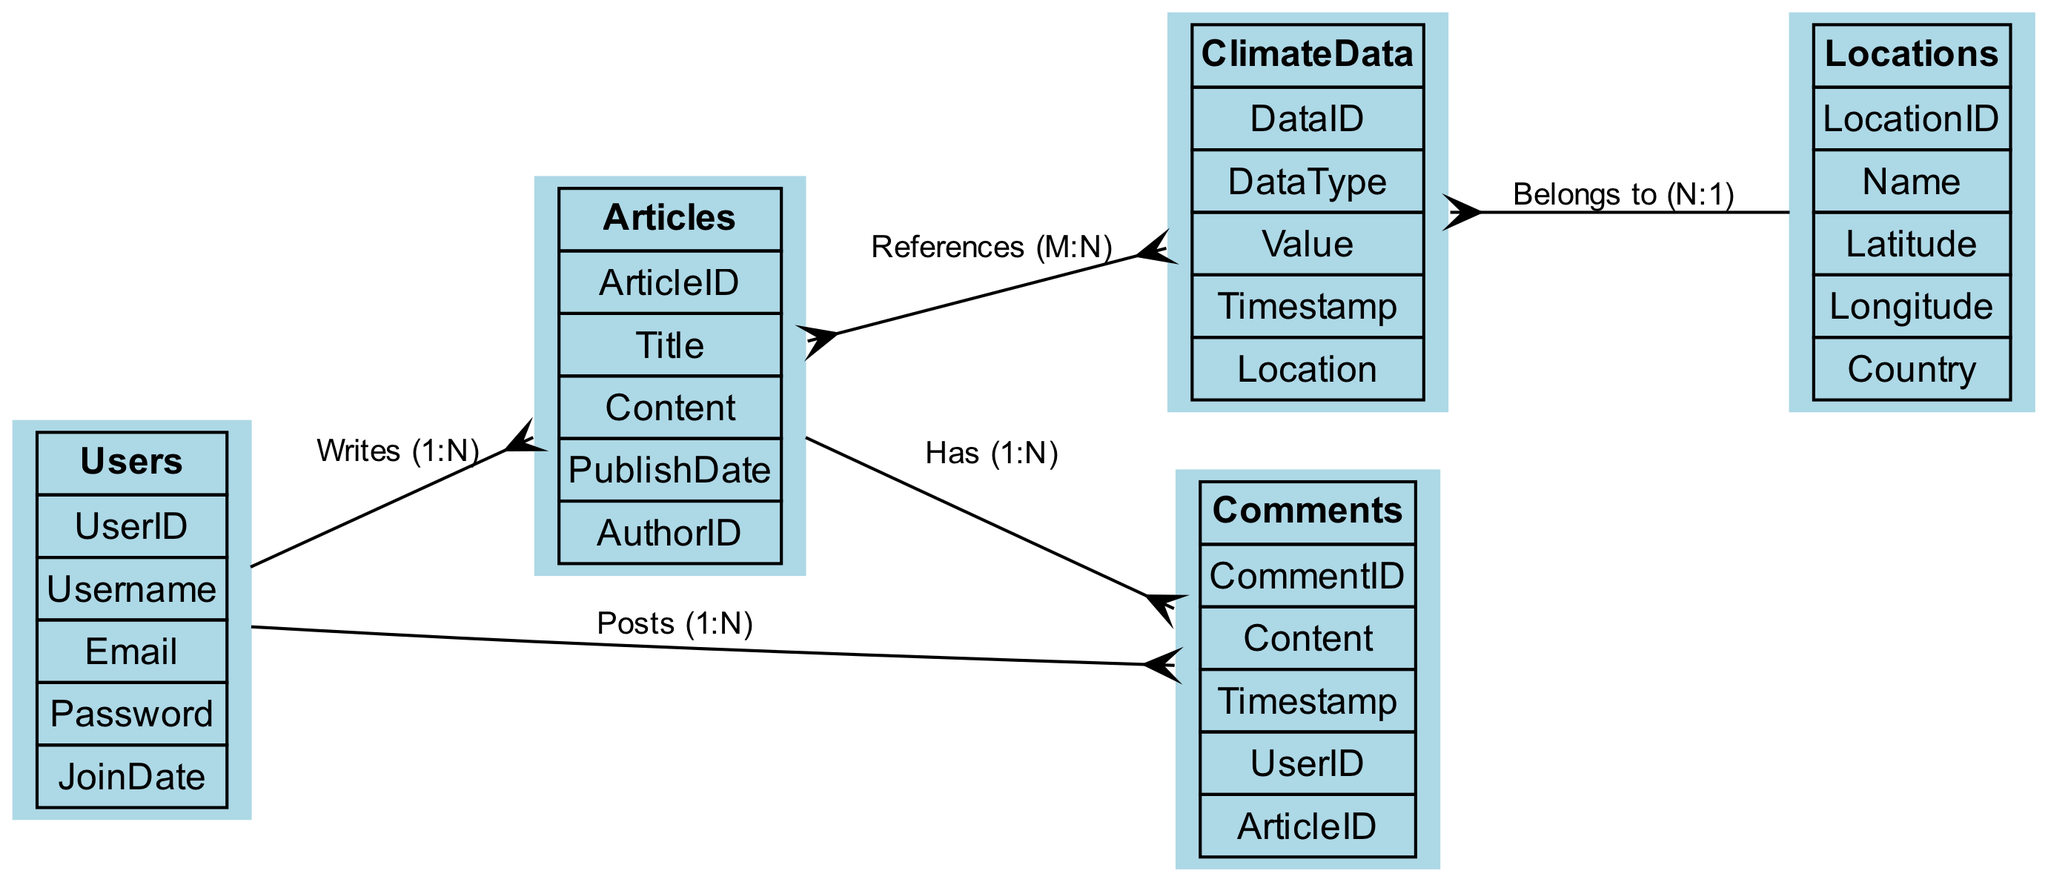What is the maximum number of articles a single user can write? The relationship between Users and Articles is labeled "Writes" with a cardinality of 1:N, indicating that a single user can write many articles. Therefore, the maximum number of articles a single user can write is technically unbounded, as there is no specified upper limit in this diagram.
Answer: N How many attributes does the ClimateData entity have? The ClimateData entity lists five attributes: DataID, DataType, Value, Timestamp, and Location. Thus, counting these attributes gives the total.
Answer: 5 Which entity has a relationship labeled "Posts"? The relationship labeled "Posts" connects the Users entity to the Comments entity, as indicated in the relationships section of the diagram. This specifies the action of users posting comments.
Answer: Comments What is the cardinality of the relationship between Articles and Comments? The diagram indicates that the relationship between Articles and Comments is labeled "Has" with a cardinality of 1:N. This means an article can have many comments, but each individual comment belongs to only one article.
Answer: 1:N Can multiple articles reference the same climate data? Yes, the relationship between Articles and ClimateData is labeled "References" with a cardinality of M:N. This means that multiple articles can reference the same climate data, and conversely, a single piece of climate data can be referenced by multiple articles.
Answer: Yes What is the connection between ClimateData and Locations? The relationship between ClimateData and Locations is labeled "Belongs to" with a cardinality of N:1, indicating that multiple pieces of climate data can relate to a single location, but each piece of climate data can only belong to one location.
Answer: Belongs to How are users connected to articles in this database? Users are connected to Articles through a relationship labeled "Writes" with a cardinality of 1:N, indicating each user can write multiple articles while any single article is associated with only one user.
Answer: Writes What attribute distinguishes the Users entity? The Users entity is uniquely identified by its UserID attribute, which serves as the primary key in the context of distinguishing different users.
Answer: UserID How many entities are present in this database diagram? There are five entities listed in the diagram: Users, ClimateData, Articles, Comments, and Locations. This counts each distinct entity defined within the database structure.
Answer: 5 